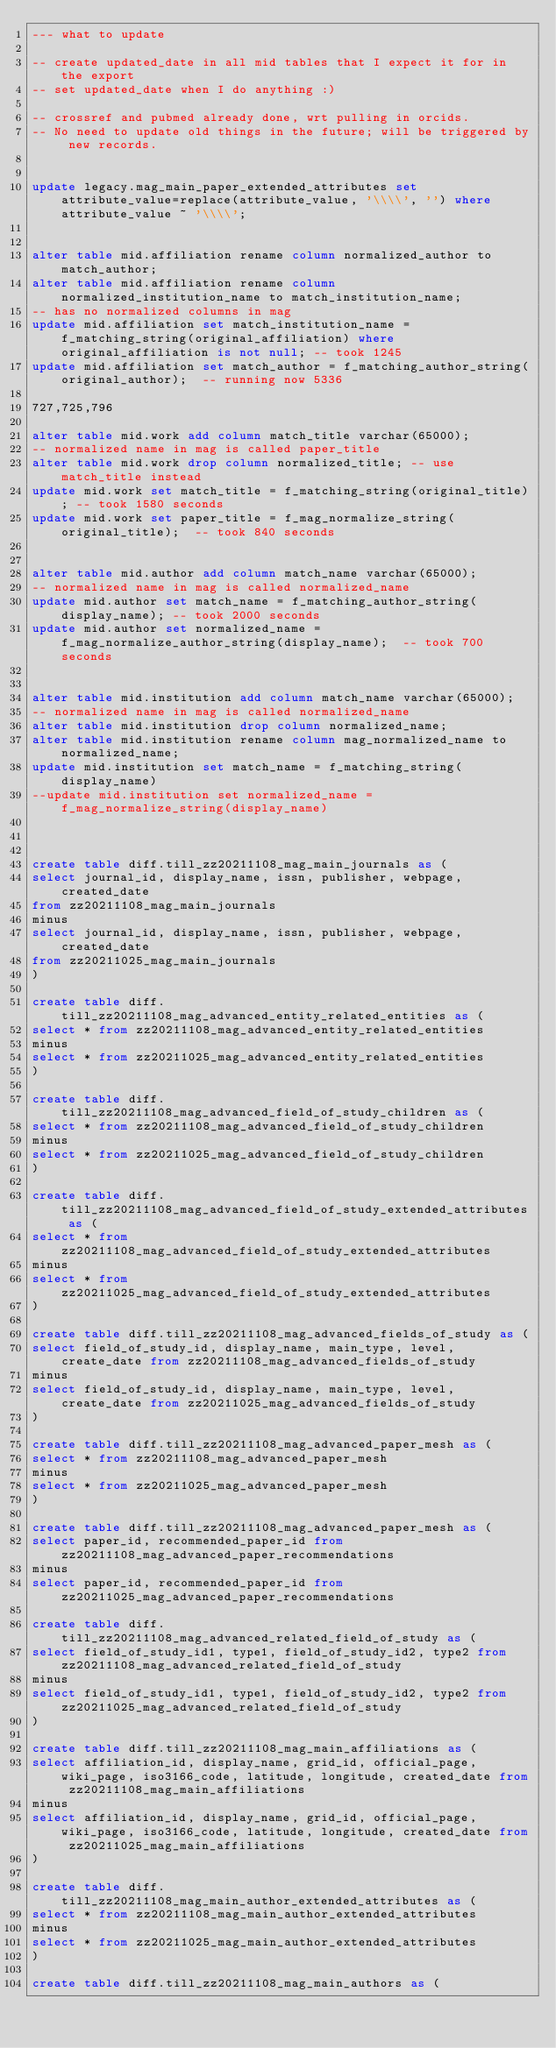Convert code to text. <code><loc_0><loc_0><loc_500><loc_500><_SQL_>--- what to update

-- create updated_date in all mid tables that I expect it for in the export
-- set updated_date when I do anything :)

-- crossref and pubmed already done, wrt pulling in orcids.
-- No need to update old things in the future; will be triggered by new records.


update legacy.mag_main_paper_extended_attributes set attribute_value=replace(attribute_value, '\\\\', '') where attribute_value ~ '\\\\';


alter table mid.affiliation rename column normalized_author to match_author;
alter table mid.affiliation rename column normalized_institution_name to match_institution_name;
-- has no normalized columns in mag
update mid.affiliation set match_institution_name = f_matching_string(original_affiliation) where original_affiliation is not null; -- took 1245
update mid.affiliation set match_author = f_matching_author_string(original_author);  -- running now 5336

727,725,796

alter table mid.work add column match_title varchar(65000);
-- normalized name in mag is called paper_title
alter table mid.work drop column normalized_title; -- use match_title instead
update mid.work set match_title = f_matching_string(original_title); -- took 1580 seconds
update mid.work set paper_title = f_mag_normalize_string(original_title);  -- took 840 seconds


alter table mid.author add column match_name varchar(65000);
-- normalized name in mag is called normalized_name
update mid.author set match_name = f_matching_author_string(display_name); -- took 2000 seconds
update mid.author set normalized_name = f_mag_normalize_author_string(display_name);  -- took 700seconds


alter table mid.institution add column match_name varchar(65000);
-- normalized name in mag is called normalized_name
alter table mid.institution drop column normalized_name;
alter table mid.institution rename column mag_normalized_name to normalized_name;
update mid.institution set match_name = f_matching_string(display_name)
--update mid.institution set normalized_name = f_mag_normalize_string(display_name)



create table diff.till_zz20211108_mag_main_journals as (
select journal_id, display_name, issn, publisher, webpage, created_date
from zz20211108_mag_main_journals
minus
select journal_id, display_name, issn, publisher, webpage, created_date
from zz20211025_mag_main_journals
)

create table diff.till_zz20211108_mag_advanced_entity_related_entities as (
select * from zz20211108_mag_advanced_entity_related_entities
minus
select * from zz20211025_mag_advanced_entity_related_entities
)

create table diff.till_zz20211108_mag_advanced_field_of_study_children as (
select * from zz20211108_mag_advanced_field_of_study_children
minus
select * from zz20211025_mag_advanced_field_of_study_children
)

create table diff.till_zz20211108_mag_advanced_field_of_study_extended_attributes as (
select * from zz20211108_mag_advanced_field_of_study_extended_attributes
minus
select * from zz20211025_mag_advanced_field_of_study_extended_attributes
)

create table diff.till_zz20211108_mag_advanced_fields_of_study as (
select field_of_study_id, display_name, main_type, level, create_date from zz20211108_mag_advanced_fields_of_study
minus
select field_of_study_id, display_name, main_type, level, create_date from zz20211025_mag_advanced_fields_of_study
)

create table diff.till_zz20211108_mag_advanced_paper_mesh as (
select * from zz20211108_mag_advanced_paper_mesh
minus
select * from zz20211025_mag_advanced_paper_mesh
)

create table diff.till_zz20211108_mag_advanced_paper_mesh as (
select paper_id, recommended_paper_id from zz20211108_mag_advanced_paper_recommendations
minus
select paper_id, recommended_paper_id from zz20211025_mag_advanced_paper_recommendations

create table diff.till_zz20211108_mag_advanced_related_field_of_study as (
select field_of_study_id1, type1, field_of_study_id2, type2 from zz20211108_mag_advanced_related_field_of_study
minus
select field_of_study_id1, type1, field_of_study_id2, type2 from zz20211025_mag_advanced_related_field_of_study
)

create table diff.till_zz20211108_mag_main_affiliations as (
select affiliation_id, display_name, grid_id, official_page, wiki_page, iso3166_code, latitude, longitude, created_date from zz20211108_mag_main_affiliations
minus
select affiliation_id, display_name, grid_id, official_page, wiki_page, iso3166_code, latitude, longitude, created_date from zz20211025_mag_main_affiliations
)

create table diff.till_zz20211108_mag_main_author_extended_attributes as (
select * from zz20211108_mag_main_author_extended_attributes
minus
select * from zz20211025_mag_main_author_extended_attributes
)

create table diff.till_zz20211108_mag_main_authors as (</code> 